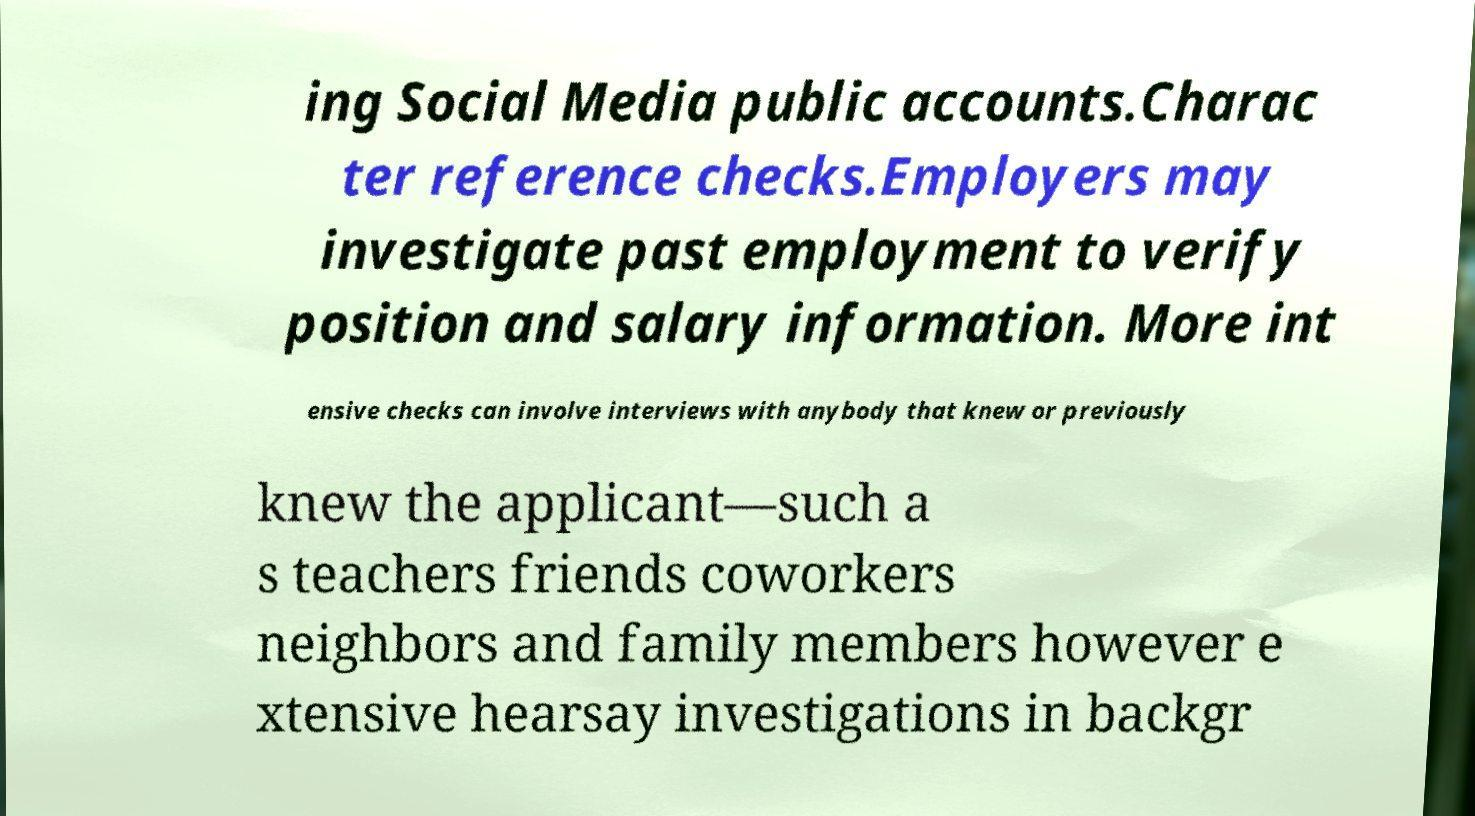Could you extract and type out the text from this image? ing Social Media public accounts.Charac ter reference checks.Employers may investigate past employment to verify position and salary information. More int ensive checks can involve interviews with anybody that knew or previously knew the applicant—such a s teachers friends coworkers neighbors and family members however e xtensive hearsay investigations in backgr 